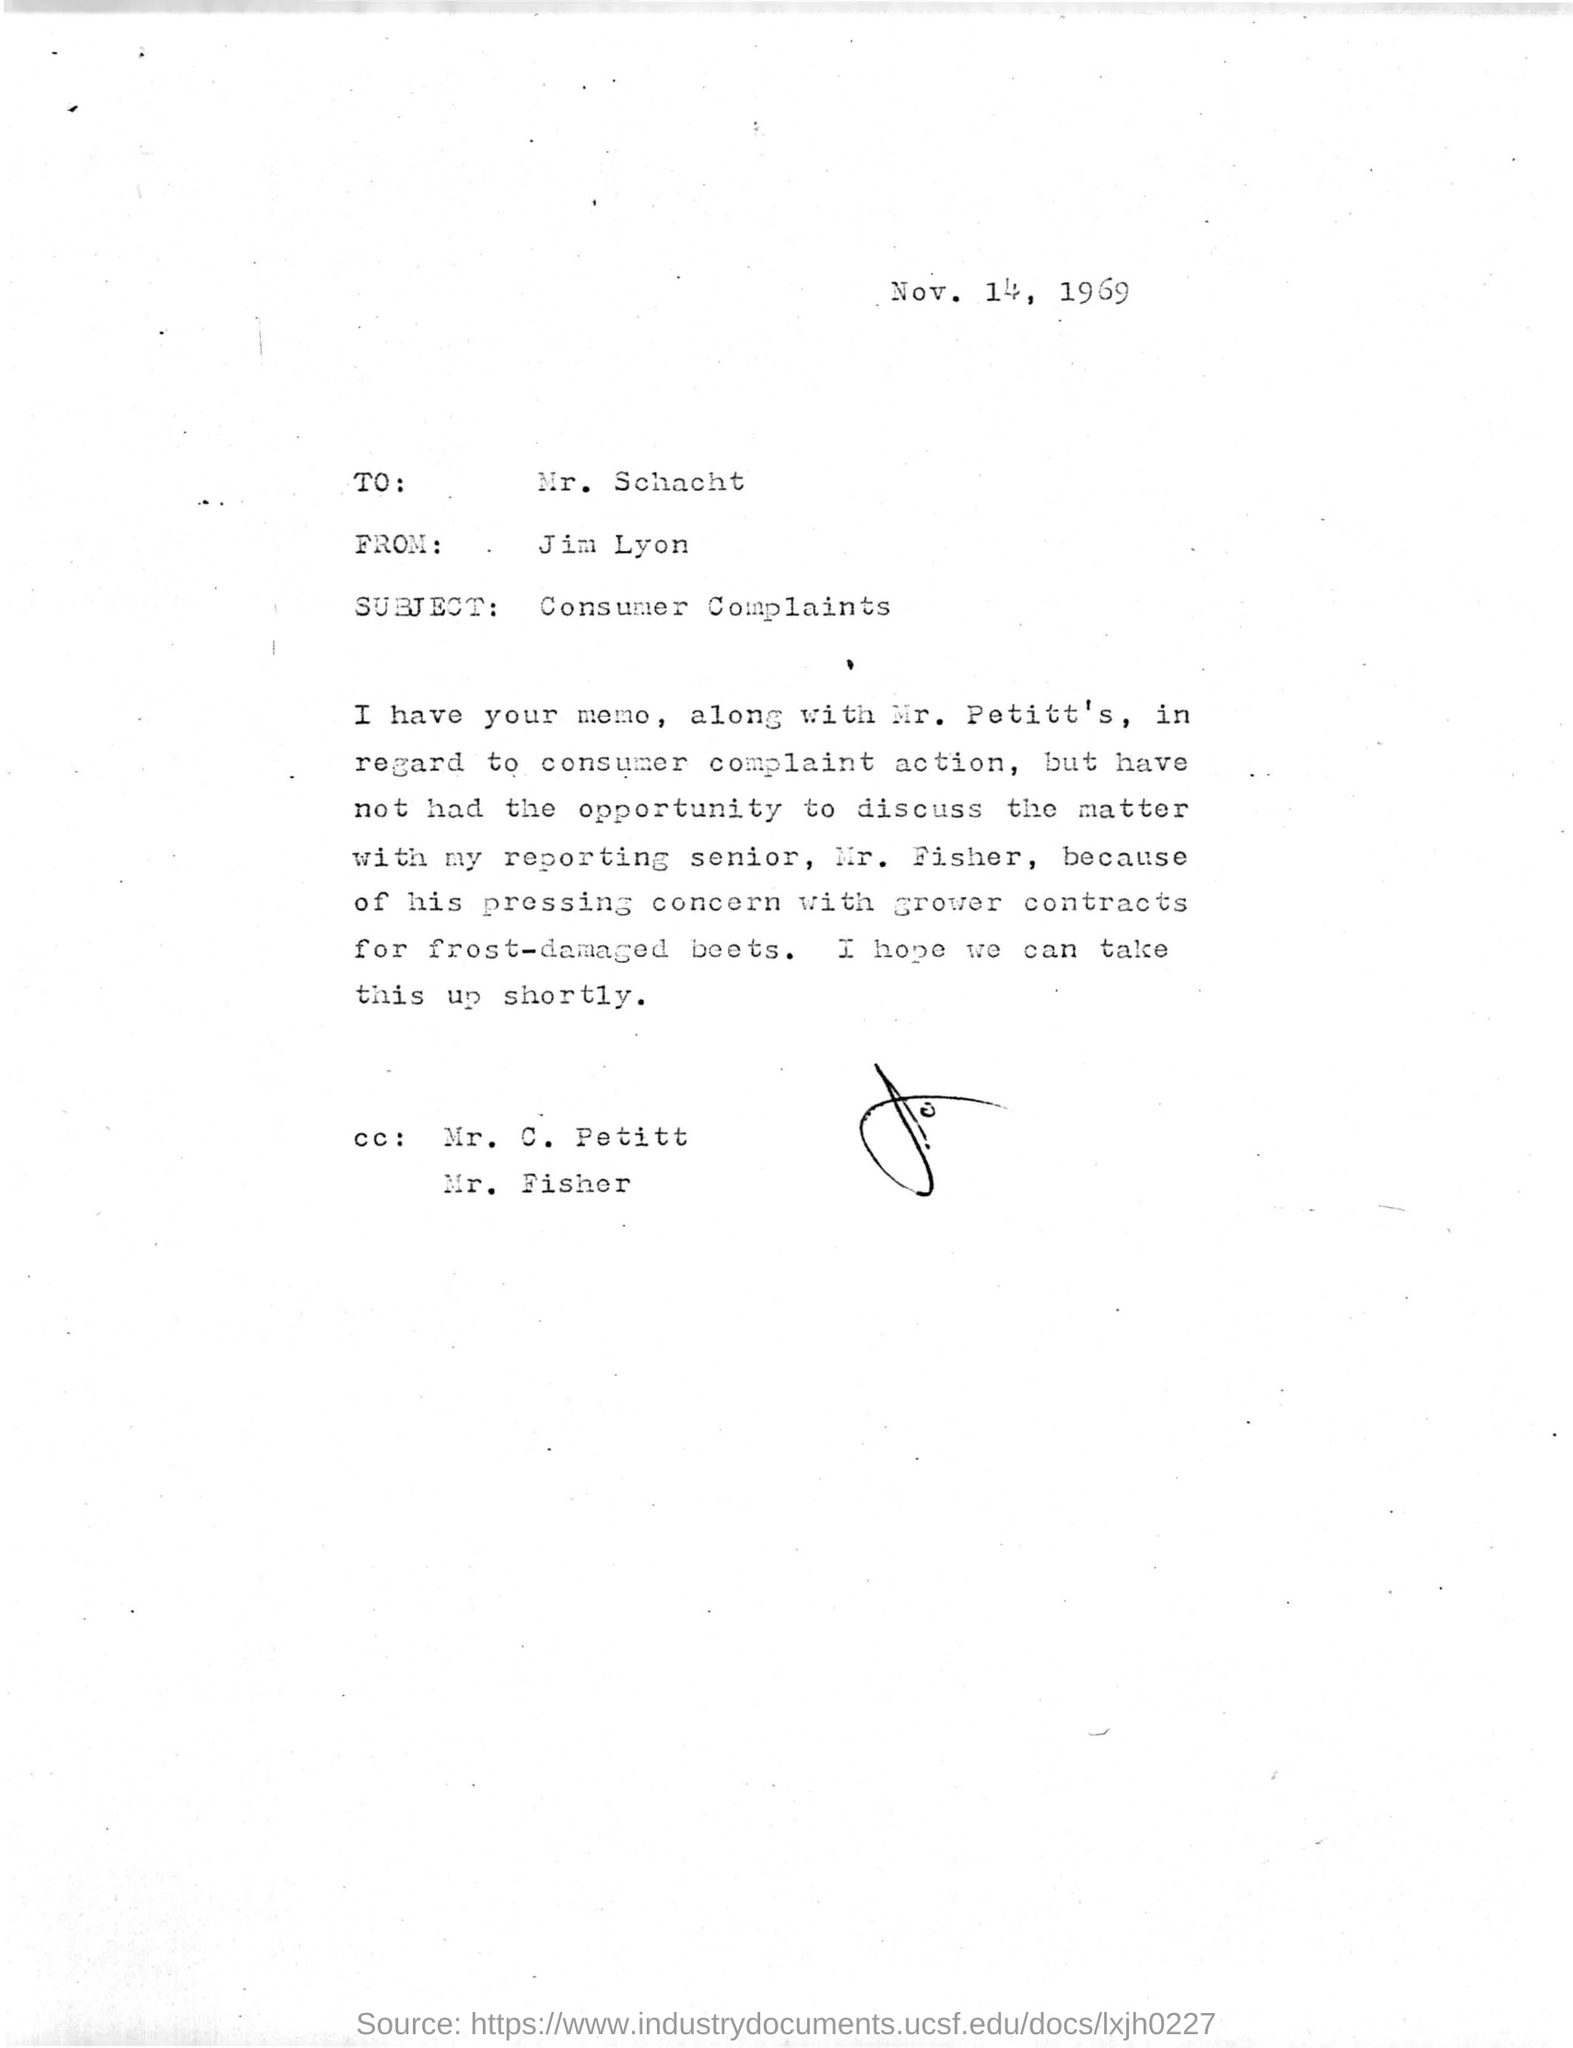To whom this was written ?
Give a very brief answer. Mr. Schacht. What is the subject of the given letter ?
Ensure brevity in your answer.  Consumer complaints. Who wrote this letter ?
Your answer should be compact. Jim lyon. On which date and year this letter was written ?
Offer a terse response. Nov. 14, 1969. 